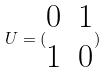<formula> <loc_0><loc_0><loc_500><loc_500>U = ( \begin{matrix} 0 & 1 \\ 1 & 0 \end{matrix} )</formula> 